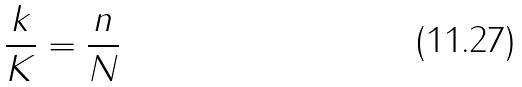Convert formula to latex. <formula><loc_0><loc_0><loc_500><loc_500>\frac { k } { K } = \frac { n } { N }</formula> 